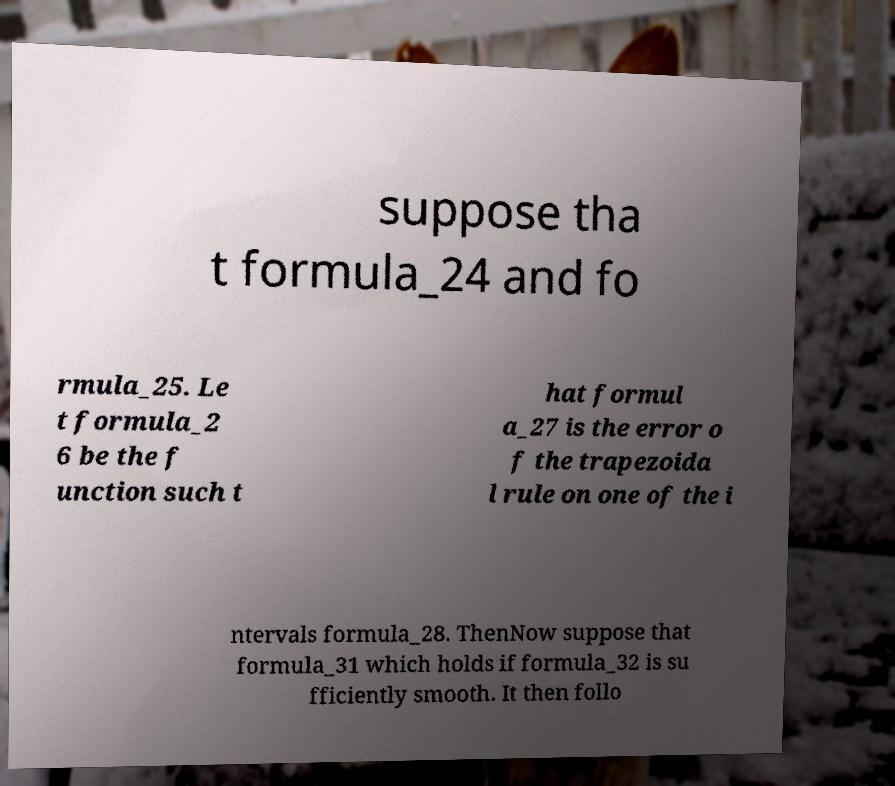Can you read and provide the text displayed in the image?This photo seems to have some interesting text. Can you extract and type it out for me? suppose tha t formula_24 and fo rmula_25. Le t formula_2 6 be the f unction such t hat formul a_27 is the error o f the trapezoida l rule on one of the i ntervals formula_28. ThenNow suppose that formula_31 which holds if formula_32 is su fficiently smooth. It then follo 